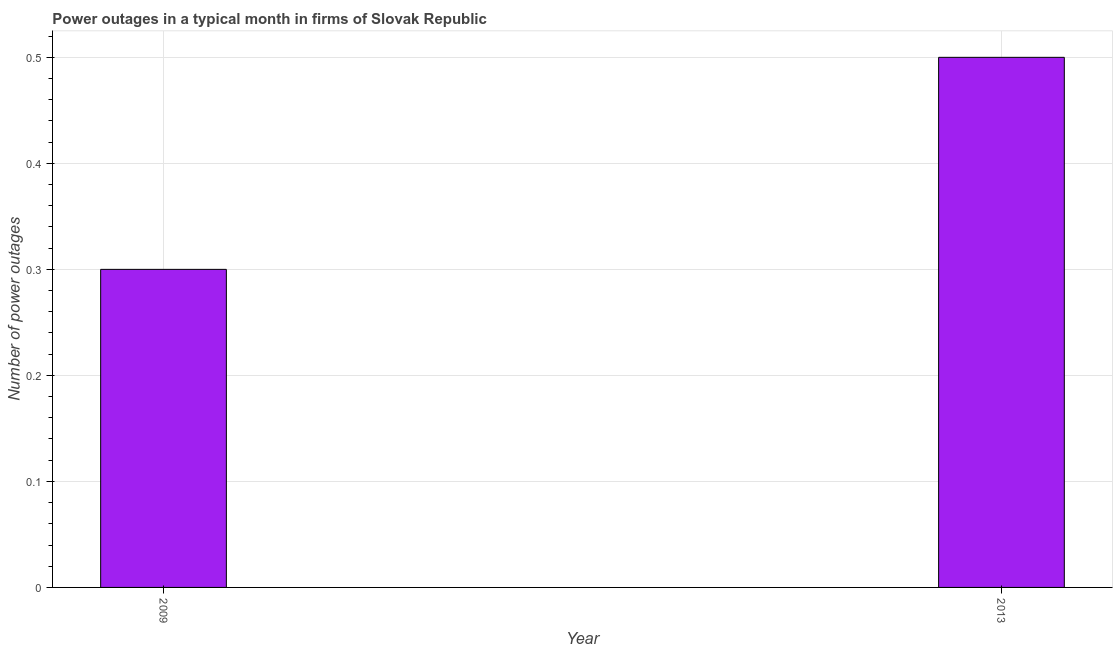What is the title of the graph?
Ensure brevity in your answer.  Power outages in a typical month in firms of Slovak Republic. What is the label or title of the Y-axis?
Provide a short and direct response. Number of power outages. In which year was the number of power outages minimum?
Make the answer very short. 2009. What is the difference between the number of power outages in 2009 and 2013?
Your response must be concise. -0.2. What is the average number of power outages per year?
Your answer should be compact. 0.4. What is the median number of power outages?
Keep it short and to the point. 0.4. In how many years, is the number of power outages greater than 0.16 ?
Your answer should be very brief. 2. How many bars are there?
Your answer should be compact. 2. What is the difference between two consecutive major ticks on the Y-axis?
Give a very brief answer. 0.1. Are the values on the major ticks of Y-axis written in scientific E-notation?
Provide a succinct answer. No. What is the Number of power outages of 2009?
Keep it short and to the point. 0.3. 